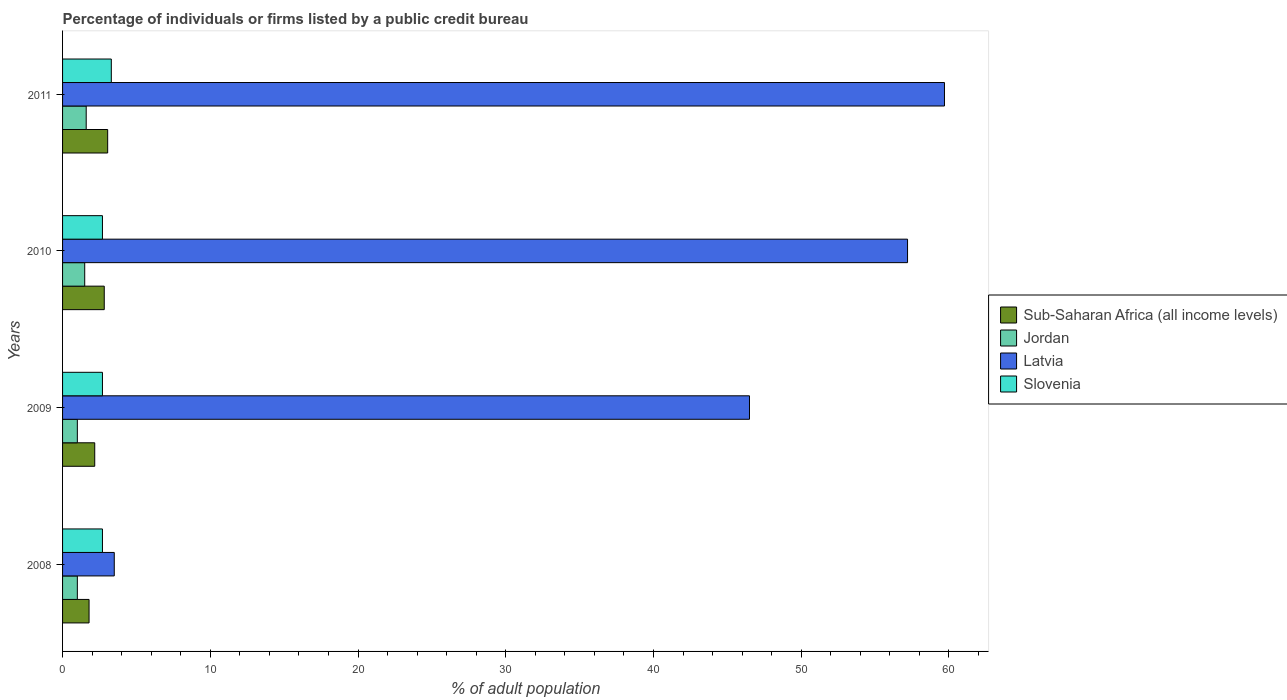How many different coloured bars are there?
Keep it short and to the point. 4. How many groups of bars are there?
Provide a succinct answer. 4. How many bars are there on the 1st tick from the top?
Your answer should be very brief. 4. What is the label of the 1st group of bars from the top?
Ensure brevity in your answer.  2011. Across all years, what is the minimum percentage of population listed by a public credit bureau in Slovenia?
Provide a succinct answer. 2.7. In which year was the percentage of population listed by a public credit bureau in Slovenia minimum?
Provide a succinct answer. 2008. What is the total percentage of population listed by a public credit bureau in Slovenia in the graph?
Your answer should be compact. 11.4. What is the difference between the percentage of population listed by a public credit bureau in Jordan in 2008 and that in 2010?
Keep it short and to the point. -0.5. What is the difference between the percentage of population listed by a public credit bureau in Latvia in 2009 and the percentage of population listed by a public credit bureau in Sub-Saharan Africa (all income levels) in 2011?
Provide a succinct answer. 43.45. What is the average percentage of population listed by a public credit bureau in Jordan per year?
Ensure brevity in your answer.  1.27. In the year 2008, what is the difference between the percentage of population listed by a public credit bureau in Jordan and percentage of population listed by a public credit bureau in Slovenia?
Provide a short and direct response. -1.7. In how many years, is the percentage of population listed by a public credit bureau in Slovenia greater than 4 %?
Offer a terse response. 0. What is the ratio of the percentage of population listed by a public credit bureau in Slovenia in 2009 to that in 2011?
Provide a succinct answer. 0.82. What is the difference between the highest and the second highest percentage of population listed by a public credit bureau in Slovenia?
Keep it short and to the point. 0.6. What is the difference between the highest and the lowest percentage of population listed by a public credit bureau in Latvia?
Ensure brevity in your answer.  56.2. In how many years, is the percentage of population listed by a public credit bureau in Latvia greater than the average percentage of population listed by a public credit bureau in Latvia taken over all years?
Give a very brief answer. 3. Is the sum of the percentage of population listed by a public credit bureau in Latvia in 2009 and 2011 greater than the maximum percentage of population listed by a public credit bureau in Jordan across all years?
Make the answer very short. Yes. What does the 3rd bar from the top in 2008 represents?
Your response must be concise. Jordan. What does the 1st bar from the bottom in 2011 represents?
Provide a short and direct response. Sub-Saharan Africa (all income levels). Is it the case that in every year, the sum of the percentage of population listed by a public credit bureau in Sub-Saharan Africa (all income levels) and percentage of population listed by a public credit bureau in Jordan is greater than the percentage of population listed by a public credit bureau in Latvia?
Provide a short and direct response. No. Are all the bars in the graph horizontal?
Provide a succinct answer. Yes. How many years are there in the graph?
Your answer should be very brief. 4. Does the graph contain any zero values?
Your answer should be very brief. No. Does the graph contain grids?
Provide a short and direct response. No. Where does the legend appear in the graph?
Keep it short and to the point. Center right. What is the title of the graph?
Your answer should be very brief. Percentage of individuals or firms listed by a public credit bureau. Does "Congo (Democratic)" appear as one of the legend labels in the graph?
Provide a short and direct response. No. What is the label or title of the X-axis?
Your answer should be very brief. % of adult population. What is the label or title of the Y-axis?
Make the answer very short. Years. What is the % of adult population in Sub-Saharan Africa (all income levels) in 2008?
Offer a very short reply. 1.79. What is the % of adult population of Sub-Saharan Africa (all income levels) in 2009?
Your answer should be very brief. 2.18. What is the % of adult population of Jordan in 2009?
Give a very brief answer. 1. What is the % of adult population in Latvia in 2009?
Your response must be concise. 46.5. What is the % of adult population of Slovenia in 2009?
Keep it short and to the point. 2.7. What is the % of adult population in Sub-Saharan Africa (all income levels) in 2010?
Your answer should be compact. 2.82. What is the % of adult population of Jordan in 2010?
Offer a very short reply. 1.5. What is the % of adult population of Latvia in 2010?
Offer a terse response. 57.2. What is the % of adult population in Sub-Saharan Africa (all income levels) in 2011?
Offer a terse response. 3.05. What is the % of adult population in Latvia in 2011?
Provide a short and direct response. 59.7. Across all years, what is the maximum % of adult population in Sub-Saharan Africa (all income levels)?
Give a very brief answer. 3.05. Across all years, what is the maximum % of adult population in Latvia?
Make the answer very short. 59.7. Across all years, what is the minimum % of adult population in Sub-Saharan Africa (all income levels)?
Your answer should be compact. 1.79. Across all years, what is the minimum % of adult population of Jordan?
Provide a short and direct response. 1. Across all years, what is the minimum % of adult population of Latvia?
Your answer should be very brief. 3.5. Across all years, what is the minimum % of adult population in Slovenia?
Your answer should be very brief. 2.7. What is the total % of adult population of Sub-Saharan Africa (all income levels) in the graph?
Your answer should be very brief. 9.85. What is the total % of adult population of Jordan in the graph?
Your answer should be very brief. 5.1. What is the total % of adult population of Latvia in the graph?
Your answer should be compact. 166.9. What is the difference between the % of adult population of Sub-Saharan Africa (all income levels) in 2008 and that in 2009?
Offer a terse response. -0.38. What is the difference between the % of adult population in Latvia in 2008 and that in 2009?
Offer a terse response. -43. What is the difference between the % of adult population in Slovenia in 2008 and that in 2009?
Offer a very short reply. 0. What is the difference between the % of adult population of Sub-Saharan Africa (all income levels) in 2008 and that in 2010?
Keep it short and to the point. -1.03. What is the difference between the % of adult population in Latvia in 2008 and that in 2010?
Make the answer very short. -53.7. What is the difference between the % of adult population of Sub-Saharan Africa (all income levels) in 2008 and that in 2011?
Offer a terse response. -1.26. What is the difference between the % of adult population of Latvia in 2008 and that in 2011?
Your answer should be compact. -56.2. What is the difference between the % of adult population of Slovenia in 2008 and that in 2011?
Keep it short and to the point. -0.6. What is the difference between the % of adult population of Sub-Saharan Africa (all income levels) in 2009 and that in 2010?
Your response must be concise. -0.64. What is the difference between the % of adult population of Jordan in 2009 and that in 2010?
Ensure brevity in your answer.  -0.5. What is the difference between the % of adult population in Latvia in 2009 and that in 2010?
Keep it short and to the point. -10.7. What is the difference between the % of adult population in Slovenia in 2009 and that in 2010?
Your response must be concise. 0. What is the difference between the % of adult population of Sub-Saharan Africa (all income levels) in 2009 and that in 2011?
Your response must be concise. -0.88. What is the difference between the % of adult population of Jordan in 2009 and that in 2011?
Your response must be concise. -0.6. What is the difference between the % of adult population in Sub-Saharan Africa (all income levels) in 2010 and that in 2011?
Give a very brief answer. -0.23. What is the difference between the % of adult population in Slovenia in 2010 and that in 2011?
Provide a succinct answer. -0.6. What is the difference between the % of adult population of Sub-Saharan Africa (all income levels) in 2008 and the % of adult population of Jordan in 2009?
Keep it short and to the point. 0.79. What is the difference between the % of adult population of Sub-Saharan Africa (all income levels) in 2008 and the % of adult population of Latvia in 2009?
Offer a very short reply. -44.71. What is the difference between the % of adult population of Sub-Saharan Africa (all income levels) in 2008 and the % of adult population of Slovenia in 2009?
Provide a succinct answer. -0.91. What is the difference between the % of adult population in Jordan in 2008 and the % of adult population in Latvia in 2009?
Offer a very short reply. -45.5. What is the difference between the % of adult population of Jordan in 2008 and the % of adult population of Slovenia in 2009?
Ensure brevity in your answer.  -1.7. What is the difference between the % of adult population of Sub-Saharan Africa (all income levels) in 2008 and the % of adult population of Jordan in 2010?
Provide a succinct answer. 0.29. What is the difference between the % of adult population of Sub-Saharan Africa (all income levels) in 2008 and the % of adult population of Latvia in 2010?
Your answer should be very brief. -55.41. What is the difference between the % of adult population in Sub-Saharan Africa (all income levels) in 2008 and the % of adult population in Slovenia in 2010?
Ensure brevity in your answer.  -0.91. What is the difference between the % of adult population of Jordan in 2008 and the % of adult population of Latvia in 2010?
Your response must be concise. -56.2. What is the difference between the % of adult population in Jordan in 2008 and the % of adult population in Slovenia in 2010?
Ensure brevity in your answer.  -1.7. What is the difference between the % of adult population of Latvia in 2008 and the % of adult population of Slovenia in 2010?
Give a very brief answer. 0.8. What is the difference between the % of adult population of Sub-Saharan Africa (all income levels) in 2008 and the % of adult population of Jordan in 2011?
Make the answer very short. 0.19. What is the difference between the % of adult population in Sub-Saharan Africa (all income levels) in 2008 and the % of adult population in Latvia in 2011?
Provide a short and direct response. -57.91. What is the difference between the % of adult population in Sub-Saharan Africa (all income levels) in 2008 and the % of adult population in Slovenia in 2011?
Give a very brief answer. -1.51. What is the difference between the % of adult population of Jordan in 2008 and the % of adult population of Latvia in 2011?
Your answer should be compact. -58.7. What is the difference between the % of adult population of Sub-Saharan Africa (all income levels) in 2009 and the % of adult population of Jordan in 2010?
Keep it short and to the point. 0.68. What is the difference between the % of adult population in Sub-Saharan Africa (all income levels) in 2009 and the % of adult population in Latvia in 2010?
Keep it short and to the point. -55.02. What is the difference between the % of adult population of Sub-Saharan Africa (all income levels) in 2009 and the % of adult population of Slovenia in 2010?
Ensure brevity in your answer.  -0.52. What is the difference between the % of adult population of Jordan in 2009 and the % of adult population of Latvia in 2010?
Your answer should be compact. -56.2. What is the difference between the % of adult population of Latvia in 2009 and the % of adult population of Slovenia in 2010?
Keep it short and to the point. 43.8. What is the difference between the % of adult population of Sub-Saharan Africa (all income levels) in 2009 and the % of adult population of Jordan in 2011?
Your answer should be very brief. 0.58. What is the difference between the % of adult population of Sub-Saharan Africa (all income levels) in 2009 and the % of adult population of Latvia in 2011?
Make the answer very short. -57.52. What is the difference between the % of adult population of Sub-Saharan Africa (all income levels) in 2009 and the % of adult population of Slovenia in 2011?
Offer a terse response. -1.12. What is the difference between the % of adult population of Jordan in 2009 and the % of adult population of Latvia in 2011?
Your answer should be compact. -58.7. What is the difference between the % of adult population of Jordan in 2009 and the % of adult population of Slovenia in 2011?
Your answer should be compact. -2.3. What is the difference between the % of adult population of Latvia in 2009 and the % of adult population of Slovenia in 2011?
Provide a short and direct response. 43.2. What is the difference between the % of adult population in Sub-Saharan Africa (all income levels) in 2010 and the % of adult population in Jordan in 2011?
Your response must be concise. 1.22. What is the difference between the % of adult population of Sub-Saharan Africa (all income levels) in 2010 and the % of adult population of Latvia in 2011?
Provide a succinct answer. -56.88. What is the difference between the % of adult population in Sub-Saharan Africa (all income levels) in 2010 and the % of adult population in Slovenia in 2011?
Keep it short and to the point. -0.48. What is the difference between the % of adult population in Jordan in 2010 and the % of adult population in Latvia in 2011?
Give a very brief answer. -58.2. What is the difference between the % of adult population in Latvia in 2010 and the % of adult population in Slovenia in 2011?
Your response must be concise. 53.9. What is the average % of adult population in Sub-Saharan Africa (all income levels) per year?
Make the answer very short. 2.46. What is the average % of adult population of Jordan per year?
Make the answer very short. 1.27. What is the average % of adult population in Latvia per year?
Ensure brevity in your answer.  41.73. What is the average % of adult population in Slovenia per year?
Your response must be concise. 2.85. In the year 2008, what is the difference between the % of adult population in Sub-Saharan Africa (all income levels) and % of adult population in Jordan?
Give a very brief answer. 0.79. In the year 2008, what is the difference between the % of adult population in Sub-Saharan Africa (all income levels) and % of adult population in Latvia?
Make the answer very short. -1.71. In the year 2008, what is the difference between the % of adult population in Sub-Saharan Africa (all income levels) and % of adult population in Slovenia?
Offer a very short reply. -0.91. In the year 2008, what is the difference between the % of adult population of Latvia and % of adult population of Slovenia?
Your answer should be very brief. 0.8. In the year 2009, what is the difference between the % of adult population of Sub-Saharan Africa (all income levels) and % of adult population of Jordan?
Provide a succinct answer. 1.18. In the year 2009, what is the difference between the % of adult population in Sub-Saharan Africa (all income levels) and % of adult population in Latvia?
Provide a succinct answer. -44.32. In the year 2009, what is the difference between the % of adult population of Sub-Saharan Africa (all income levels) and % of adult population of Slovenia?
Provide a succinct answer. -0.52. In the year 2009, what is the difference between the % of adult population of Jordan and % of adult population of Latvia?
Ensure brevity in your answer.  -45.5. In the year 2009, what is the difference between the % of adult population of Latvia and % of adult population of Slovenia?
Offer a very short reply. 43.8. In the year 2010, what is the difference between the % of adult population of Sub-Saharan Africa (all income levels) and % of adult population of Jordan?
Keep it short and to the point. 1.32. In the year 2010, what is the difference between the % of adult population of Sub-Saharan Africa (all income levels) and % of adult population of Latvia?
Your answer should be very brief. -54.38. In the year 2010, what is the difference between the % of adult population in Sub-Saharan Africa (all income levels) and % of adult population in Slovenia?
Your answer should be compact. 0.12. In the year 2010, what is the difference between the % of adult population of Jordan and % of adult population of Latvia?
Provide a short and direct response. -55.7. In the year 2010, what is the difference between the % of adult population of Jordan and % of adult population of Slovenia?
Provide a short and direct response. -1.2. In the year 2010, what is the difference between the % of adult population in Latvia and % of adult population in Slovenia?
Your response must be concise. 54.5. In the year 2011, what is the difference between the % of adult population of Sub-Saharan Africa (all income levels) and % of adult population of Jordan?
Provide a succinct answer. 1.45. In the year 2011, what is the difference between the % of adult population of Sub-Saharan Africa (all income levels) and % of adult population of Latvia?
Your answer should be compact. -56.65. In the year 2011, what is the difference between the % of adult population of Sub-Saharan Africa (all income levels) and % of adult population of Slovenia?
Offer a very short reply. -0.25. In the year 2011, what is the difference between the % of adult population of Jordan and % of adult population of Latvia?
Provide a short and direct response. -58.1. In the year 2011, what is the difference between the % of adult population of Jordan and % of adult population of Slovenia?
Offer a terse response. -1.7. In the year 2011, what is the difference between the % of adult population of Latvia and % of adult population of Slovenia?
Offer a terse response. 56.4. What is the ratio of the % of adult population in Sub-Saharan Africa (all income levels) in 2008 to that in 2009?
Offer a terse response. 0.82. What is the ratio of the % of adult population of Jordan in 2008 to that in 2009?
Your answer should be very brief. 1. What is the ratio of the % of adult population of Latvia in 2008 to that in 2009?
Your response must be concise. 0.08. What is the ratio of the % of adult population in Sub-Saharan Africa (all income levels) in 2008 to that in 2010?
Your answer should be very brief. 0.64. What is the ratio of the % of adult population in Latvia in 2008 to that in 2010?
Ensure brevity in your answer.  0.06. What is the ratio of the % of adult population of Sub-Saharan Africa (all income levels) in 2008 to that in 2011?
Your answer should be compact. 0.59. What is the ratio of the % of adult population of Latvia in 2008 to that in 2011?
Your answer should be compact. 0.06. What is the ratio of the % of adult population of Slovenia in 2008 to that in 2011?
Give a very brief answer. 0.82. What is the ratio of the % of adult population of Sub-Saharan Africa (all income levels) in 2009 to that in 2010?
Your answer should be compact. 0.77. What is the ratio of the % of adult population in Latvia in 2009 to that in 2010?
Your answer should be very brief. 0.81. What is the ratio of the % of adult population in Sub-Saharan Africa (all income levels) in 2009 to that in 2011?
Keep it short and to the point. 0.71. What is the ratio of the % of adult population of Jordan in 2009 to that in 2011?
Your answer should be very brief. 0.62. What is the ratio of the % of adult population in Latvia in 2009 to that in 2011?
Offer a terse response. 0.78. What is the ratio of the % of adult population of Slovenia in 2009 to that in 2011?
Make the answer very short. 0.82. What is the ratio of the % of adult population in Sub-Saharan Africa (all income levels) in 2010 to that in 2011?
Your answer should be very brief. 0.92. What is the ratio of the % of adult population of Jordan in 2010 to that in 2011?
Your response must be concise. 0.94. What is the ratio of the % of adult population of Latvia in 2010 to that in 2011?
Your response must be concise. 0.96. What is the ratio of the % of adult population in Slovenia in 2010 to that in 2011?
Your response must be concise. 0.82. What is the difference between the highest and the second highest % of adult population of Sub-Saharan Africa (all income levels)?
Give a very brief answer. 0.23. What is the difference between the highest and the second highest % of adult population in Jordan?
Provide a short and direct response. 0.1. What is the difference between the highest and the second highest % of adult population in Slovenia?
Give a very brief answer. 0.6. What is the difference between the highest and the lowest % of adult population of Sub-Saharan Africa (all income levels)?
Provide a succinct answer. 1.26. What is the difference between the highest and the lowest % of adult population of Jordan?
Your answer should be very brief. 0.6. What is the difference between the highest and the lowest % of adult population in Latvia?
Ensure brevity in your answer.  56.2. 